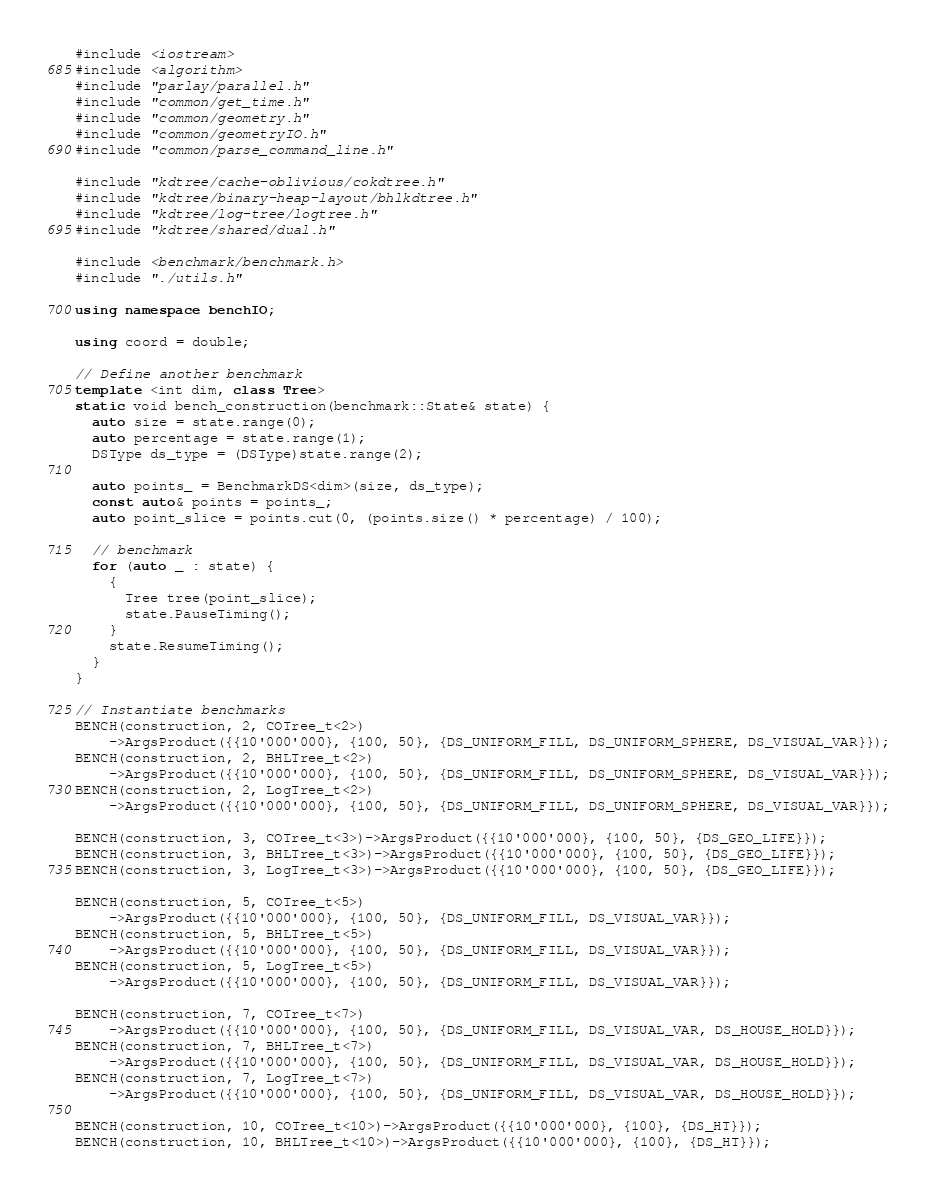Convert code to text. <code><loc_0><loc_0><loc_500><loc_500><_C++_>#include <iostream>
#include <algorithm>
#include "parlay/parallel.h"
#include "common/get_time.h"
#include "common/geometry.h"
#include "common/geometryIO.h"
#include "common/parse_command_line.h"

#include "kdtree/cache-oblivious/cokdtree.h"
#include "kdtree/binary-heap-layout/bhlkdtree.h"
#include "kdtree/log-tree/logtree.h"
#include "kdtree/shared/dual.h"

#include <benchmark/benchmark.h>
#include "./utils.h"

using namespace benchIO;

using coord = double;

// Define another benchmark
template <int dim, class Tree>
static void bench_construction(benchmark::State& state) {
  auto size = state.range(0);
  auto percentage = state.range(1);
  DSType ds_type = (DSType)state.range(2);

  auto points_ = BenchmarkDS<dim>(size, ds_type);
  const auto& points = points_;
  auto point_slice = points.cut(0, (points.size() * percentage) / 100);

  // benchmark
  for (auto _ : state) {
    {
      Tree tree(point_slice);
      state.PauseTiming();
    }
    state.ResumeTiming();
  }
}

// Instantiate benchmarks
BENCH(construction, 2, COTree_t<2>)
    ->ArgsProduct({{10'000'000}, {100, 50}, {DS_UNIFORM_FILL, DS_UNIFORM_SPHERE, DS_VISUAL_VAR}});
BENCH(construction, 2, BHLTree_t<2>)
    ->ArgsProduct({{10'000'000}, {100, 50}, {DS_UNIFORM_FILL, DS_UNIFORM_SPHERE, DS_VISUAL_VAR}});
BENCH(construction, 2, LogTree_t<2>)
    ->ArgsProduct({{10'000'000}, {100, 50}, {DS_UNIFORM_FILL, DS_UNIFORM_SPHERE, DS_VISUAL_VAR}});

BENCH(construction, 3, COTree_t<3>)->ArgsProduct({{10'000'000}, {100, 50}, {DS_GEO_LIFE}});
BENCH(construction, 3, BHLTree_t<3>)->ArgsProduct({{10'000'000}, {100, 50}, {DS_GEO_LIFE}});
BENCH(construction, 3, LogTree_t<3>)->ArgsProduct({{10'000'000}, {100, 50}, {DS_GEO_LIFE}});

BENCH(construction, 5, COTree_t<5>)
    ->ArgsProduct({{10'000'000}, {100, 50}, {DS_UNIFORM_FILL, DS_VISUAL_VAR}});
BENCH(construction, 5, BHLTree_t<5>)
    ->ArgsProduct({{10'000'000}, {100, 50}, {DS_UNIFORM_FILL, DS_VISUAL_VAR}});
BENCH(construction, 5, LogTree_t<5>)
    ->ArgsProduct({{10'000'000}, {100, 50}, {DS_UNIFORM_FILL, DS_VISUAL_VAR}});

BENCH(construction, 7, COTree_t<7>)
    ->ArgsProduct({{10'000'000}, {100, 50}, {DS_UNIFORM_FILL, DS_VISUAL_VAR, DS_HOUSE_HOLD}});
BENCH(construction, 7, BHLTree_t<7>)
    ->ArgsProduct({{10'000'000}, {100, 50}, {DS_UNIFORM_FILL, DS_VISUAL_VAR, DS_HOUSE_HOLD}});
BENCH(construction, 7, LogTree_t<7>)
    ->ArgsProduct({{10'000'000}, {100, 50}, {DS_UNIFORM_FILL, DS_VISUAL_VAR, DS_HOUSE_HOLD}});

BENCH(construction, 10, COTree_t<10>)->ArgsProduct({{10'000'000}, {100}, {DS_HT}});
BENCH(construction, 10, BHLTree_t<10>)->ArgsProduct({{10'000'000}, {100}, {DS_HT}});</code> 